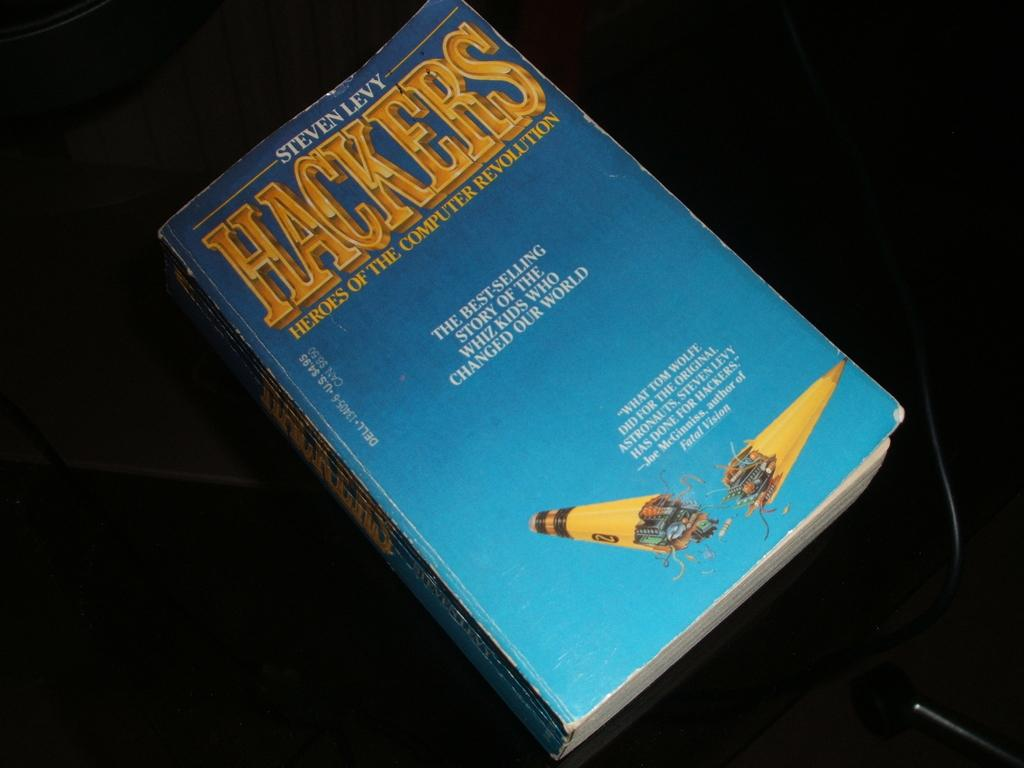<image>
Share a concise interpretation of the image provided. Steven Levy is the author of the book displayed here. 